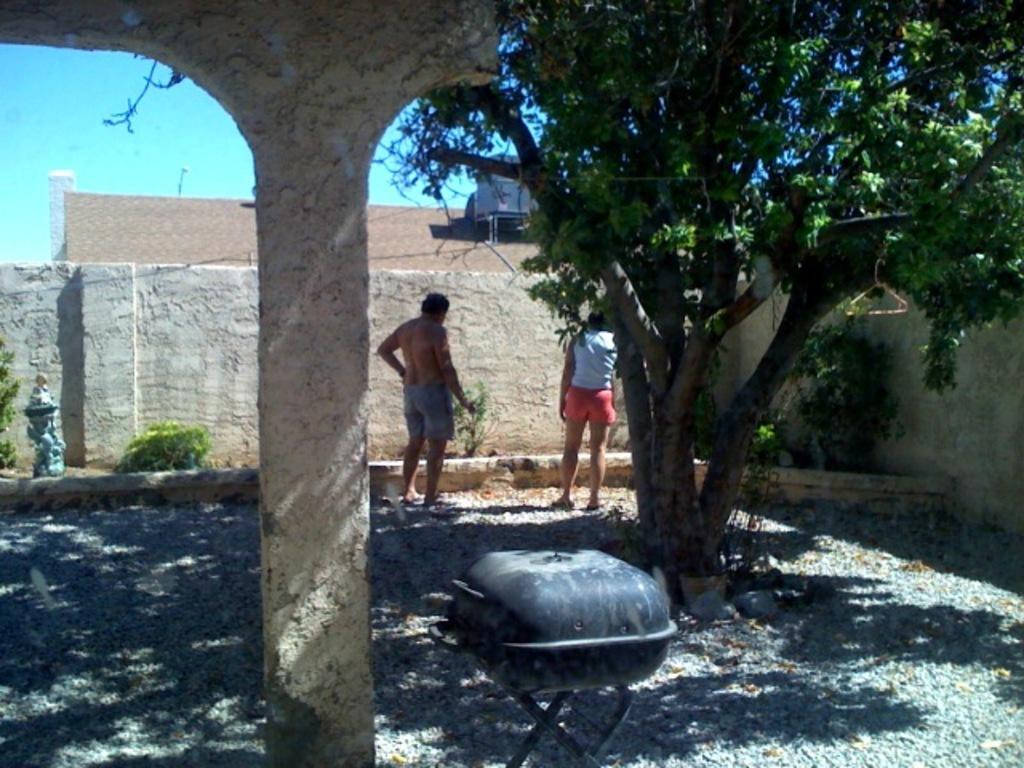Could you give a brief overview of what you see in this image? In this picture we can see 2 people standing in a place with trees & plants. Here we can see a grill stand. 